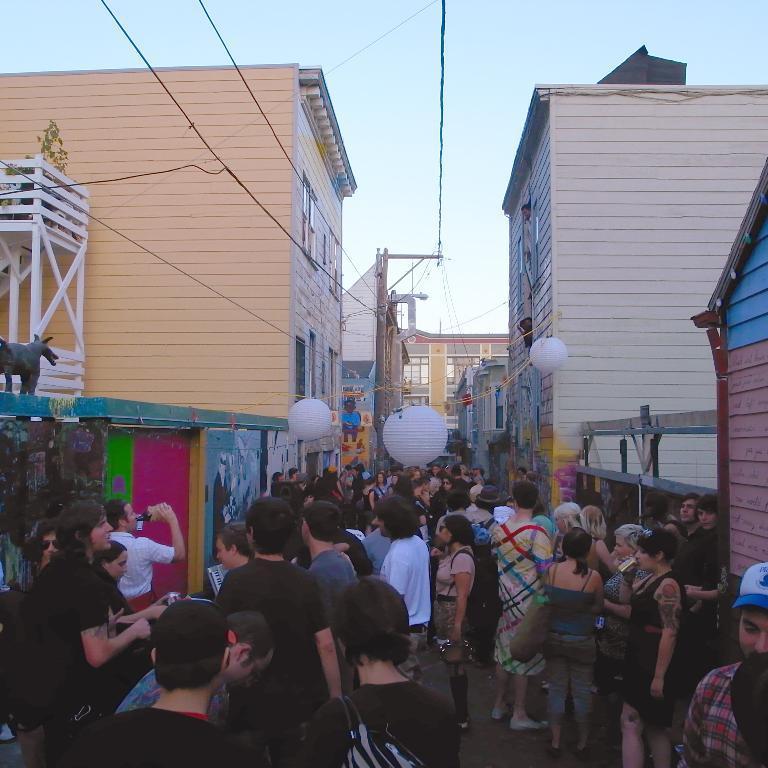Could you give a brief overview of what you see in this image? In this image we can see so many people are standing on road, both side of the road buildings are available and electricity poles are present on the top of the image. 